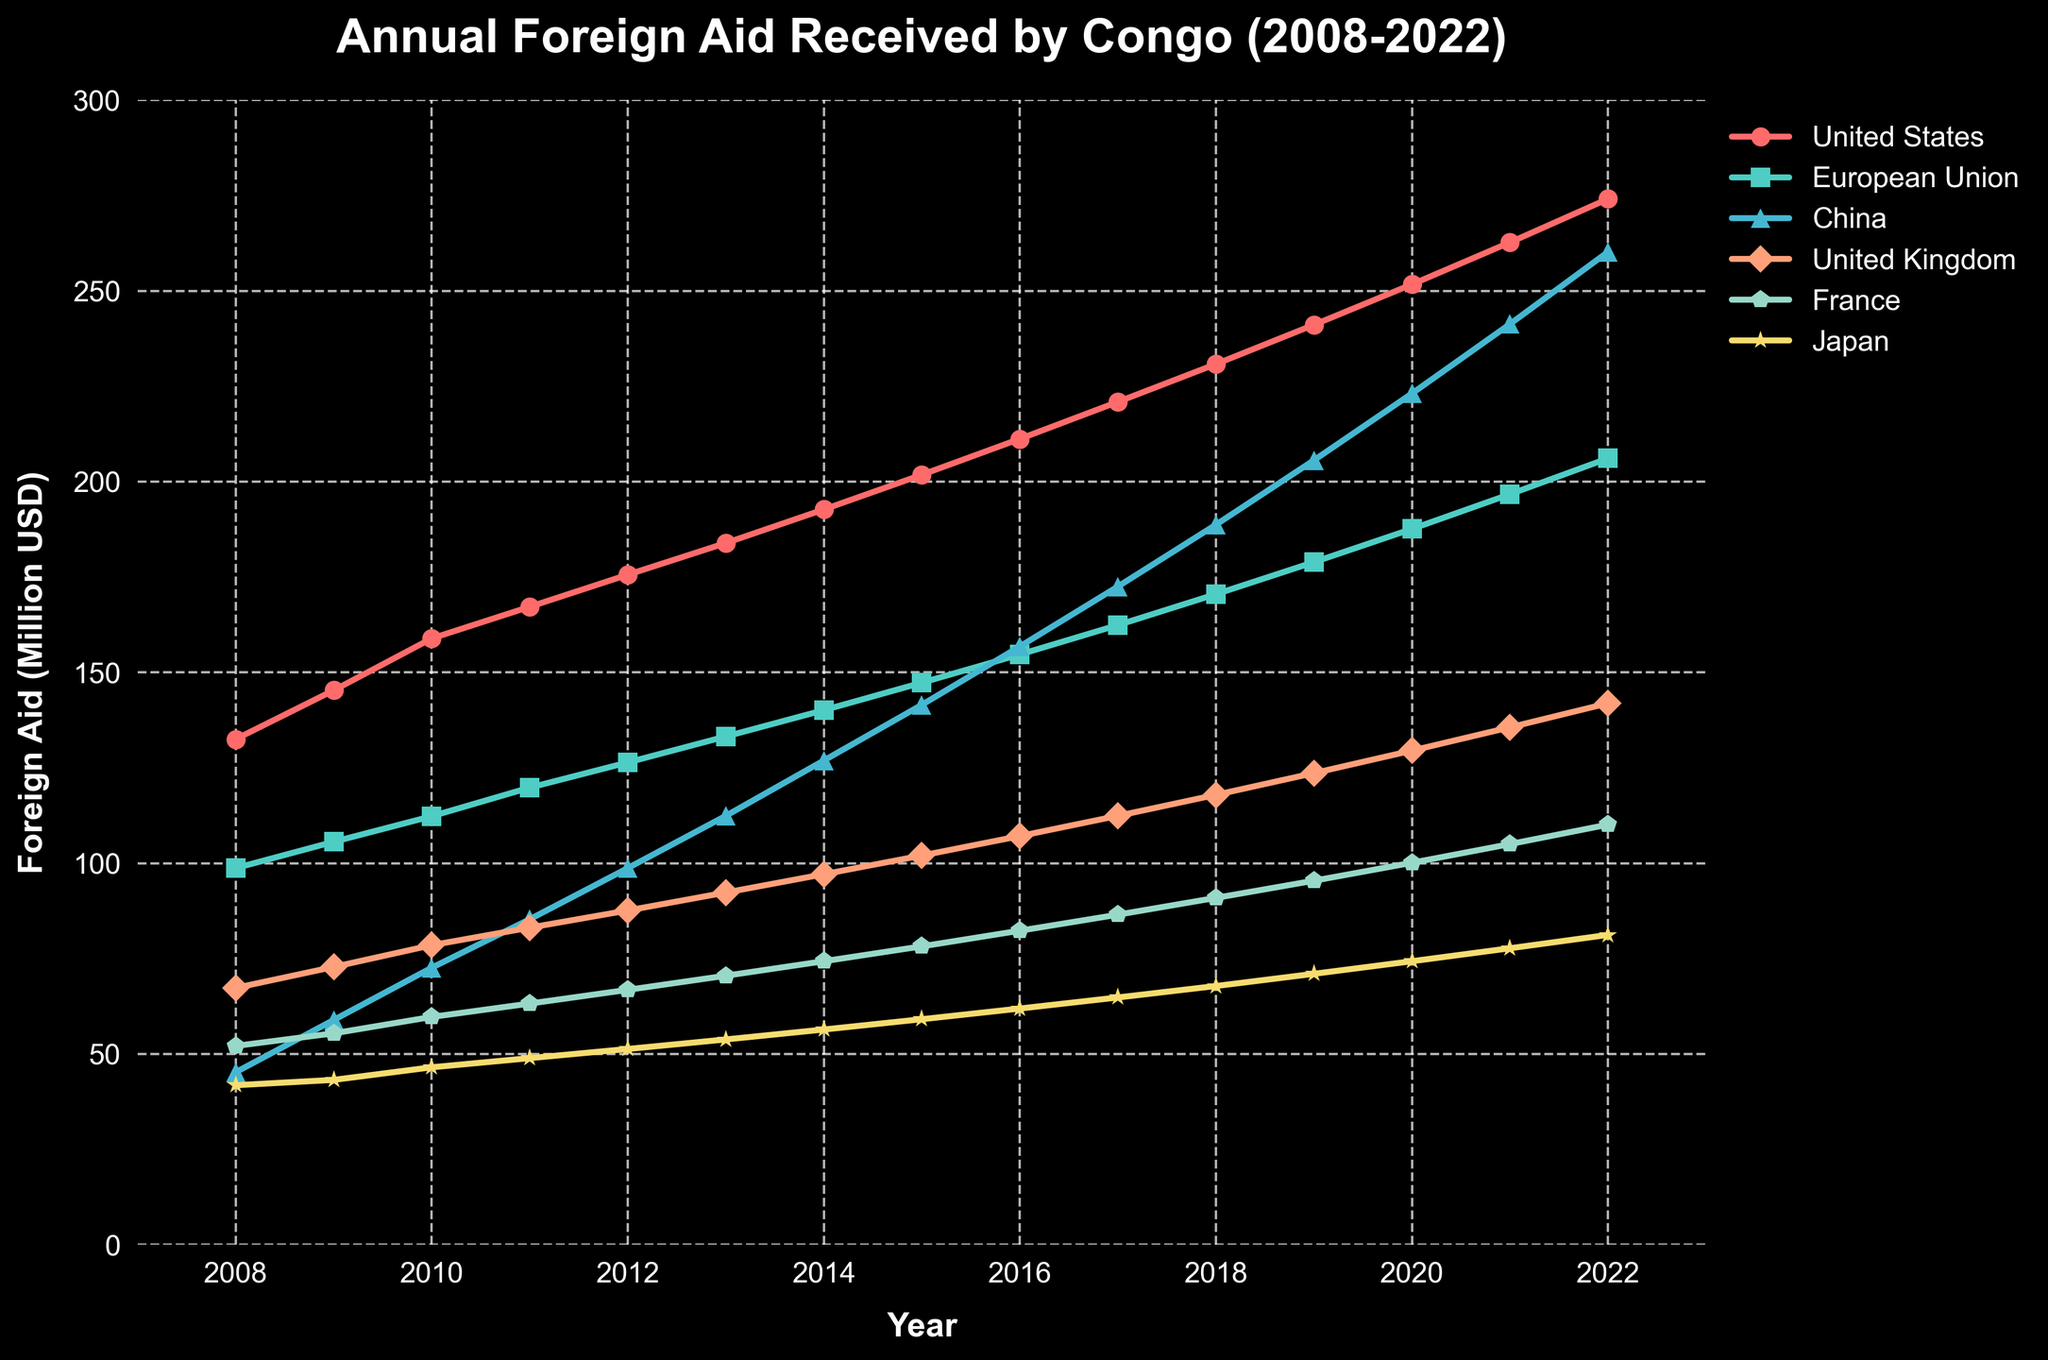What is the trend of foreign aid received from China over the years? The line for China rises steadily each year, showing an increasing trend in foreign aid from 45.2 million USD in 2008 to 260.2 million USD in 2022.
Answer: Increasing Which country provided the highest amount of foreign aid in 2022? By comparing the end points of each line, the United States provided the highest amount of foreign aid in 2022, reaching 274.1 million USD.
Answer: United States Between 2010 and 2011, which country showed the highest increase in foreign aid? By observing the steepness of the lines between 2010 and 2011, China shows the highest increase from 72.6 million USD to 85.3 million USD, a difference of 12.7 million USD.
Answer: China Which country showed the least variability in the foreign aid provided over the 15 years? The line for Japan appears the flattest compared to others, indicating the least variability in the foreign aid amount, ranging between 41.8 million USD and 81.2 million USD.
Answer: Japan What is the sum of foreign aid received from the United Kingdom and France in 2015? The aid from the United Kingdom in 2015 is 102.0 million USD and from France is 78.2 million USD. Summing these gives 102.0 + 78.2 = 180.2 million USD.
Answer: 180.2 million USD How did the foreign aid received from the European Union change from 2008 to 2022? The aid from the European Union in 2008 was 98.7 million USD and increased to 206.1 million USD in 2022. The change is 206.1 - 98.7 = 107.4 million USD.
Answer: Increased by 107.4 million USD In which year did the United States cross the 200 million USD mark in foreign aid? The United States crossed the 200 million USD mark in 2015, with an aid amount of 201.8 million USD.
Answer: 2015 Which two countries saw the most similar trends in foreign aid changes over these years? Visually, the lines for Japan and France show similar trends with a steady rise over the years.
Answer: Japan and France Compare the foreign aid received from the United Kingdom and China in 2018. Which was greater and by how much? In 2018, the United Kingdom provided 117.9 million USD, while China offered 188.7 million USD. The aid from China was greater by 188.7 - 117.9 = 70.8 million USD.
Answer: China, by 70.8 million USD By how much did the foreign aid from Japan increase between 2008 and 2022? Japan's foreign aid in 2008 was 41.8 million USD and in 2022 was 81.2 million USD, so the increase is 81.2 - 41.8 = 39.4 million USD.
Answer: 39.4 million USD 